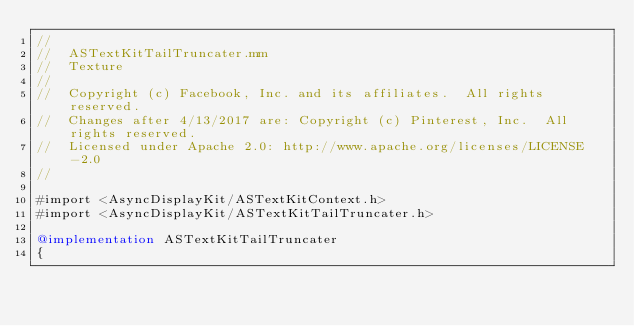Convert code to text. <code><loc_0><loc_0><loc_500><loc_500><_ObjectiveC_>//
//  ASTextKitTailTruncater.mm
//  Texture
//
//  Copyright (c) Facebook, Inc. and its affiliates.  All rights reserved.
//  Changes after 4/13/2017 are: Copyright (c) Pinterest, Inc.  All rights reserved.
//  Licensed under Apache 2.0: http://www.apache.org/licenses/LICENSE-2.0
//

#import <AsyncDisplayKit/ASTextKitContext.h>
#import <AsyncDisplayKit/ASTextKitTailTruncater.h>

@implementation ASTextKitTailTruncater
{</code> 